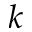Convert formula to latex. <formula><loc_0><loc_0><loc_500><loc_500>k</formula> 